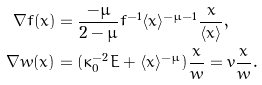<formula> <loc_0><loc_0><loc_500><loc_500>\nabla f ( x ) & = \frac { - \mu } { 2 - \mu } f ^ { - 1 } \langle x \rangle ^ { - \mu - 1 } \frac { x } { \langle x \rangle } , \\ \nabla w ( x ) & = ( \kappa _ { 0 } ^ { - 2 } E + \langle x \rangle ^ { - \mu } ) \frac { x } { w } = v \frac { x } { w } .</formula> 